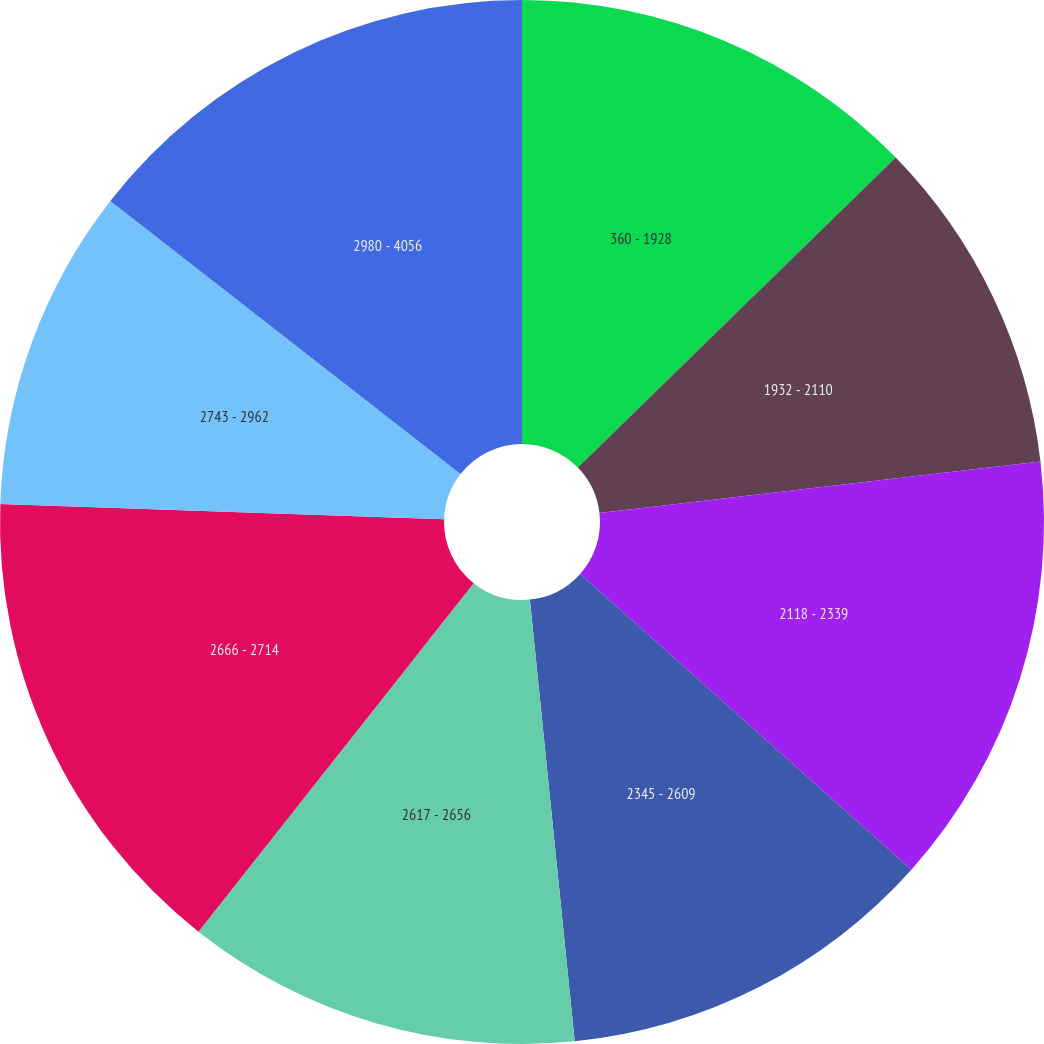<chart> <loc_0><loc_0><loc_500><loc_500><pie_chart><fcel>360 - 1928<fcel>1932 - 2110<fcel>2118 - 2339<fcel>2345 - 2609<fcel>2617 - 2656<fcel>2666 - 2714<fcel>2743 - 2962<fcel>2980 - 4056<nl><fcel>12.7%<fcel>10.45%<fcel>13.45%<fcel>11.79%<fcel>12.25%<fcel>14.91%<fcel>9.99%<fcel>14.46%<nl></chart> 